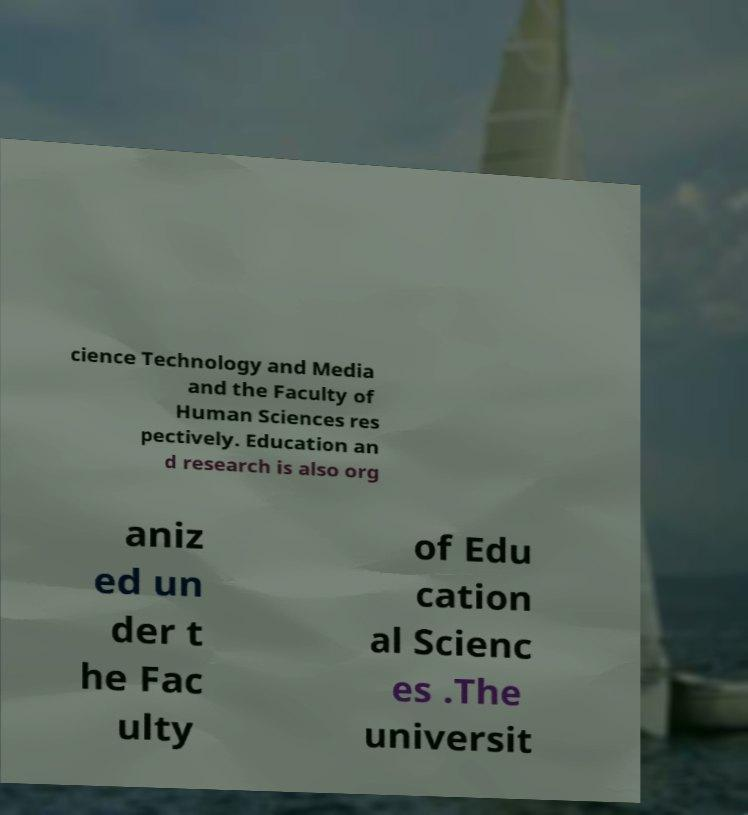Please read and relay the text visible in this image. What does it say? cience Technology and Media and the Faculty of Human Sciences res pectively. Education an d research is also org aniz ed un der t he Fac ulty of Edu cation al Scienc es .The universit 